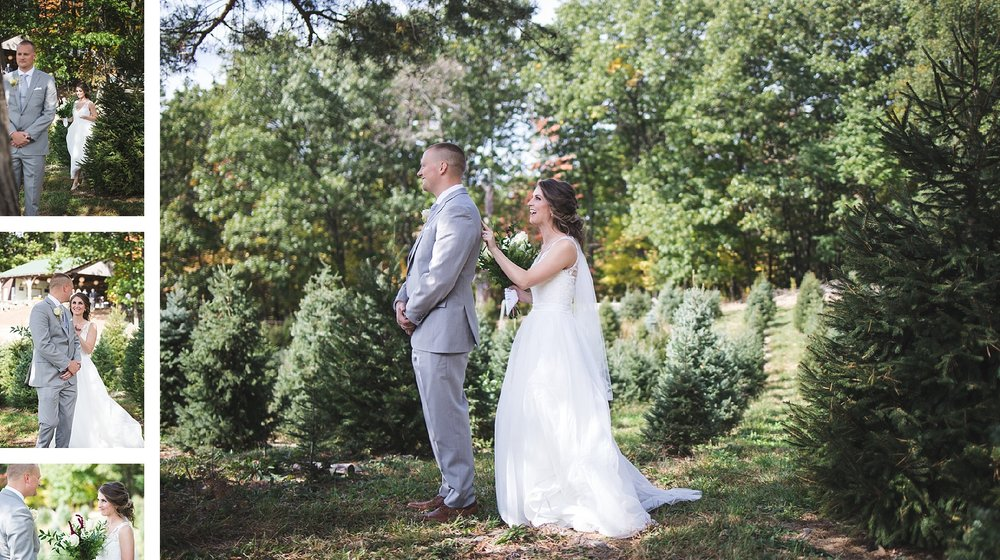Considering the setting and attire of the individuals, what time of year does this wedding likely take place, and what are the indicators of this in the image? Judging from the image, this wedding most likely occurs in the warmer months, possibly early summer. The trees are lush and fully leaved, which suggests it is not the start of spring when foliage is just beginning to grow. The bride and groom are comfortably dressed for warm weather; the bride's gown is sleeveless and light, suitable for a summer climate, while the groom's light grey suit is less formal and seems chosen for comfort in warmer conditions. The sun casts strong, well-defined shadows, indicating that the wedding takes place on a day that enjoys ample sunshine and clear skies, which are characteristic of the summer season. These factors, combined with the absence of people dressed for cooler temperatures, make early summer a plausible time for this joyous event. 